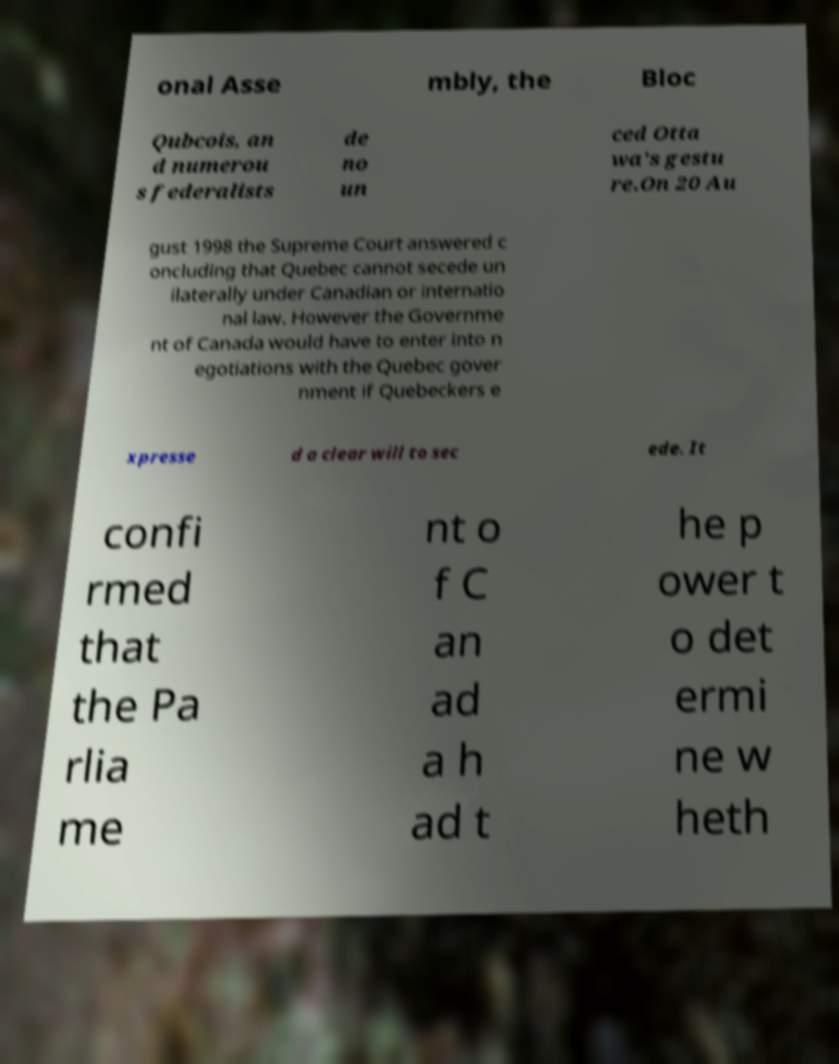For documentation purposes, I need the text within this image transcribed. Could you provide that? onal Asse mbly, the Bloc Qubcois, an d numerou s federalists de no un ced Otta wa's gestu re.On 20 Au gust 1998 the Supreme Court answered c oncluding that Quebec cannot secede un ilaterally under Canadian or internatio nal law. However the Governme nt of Canada would have to enter into n egotiations with the Quebec gover nment if Quebeckers e xpresse d a clear will to sec ede. It confi rmed that the Pa rlia me nt o f C an ad a h ad t he p ower t o det ermi ne w heth 